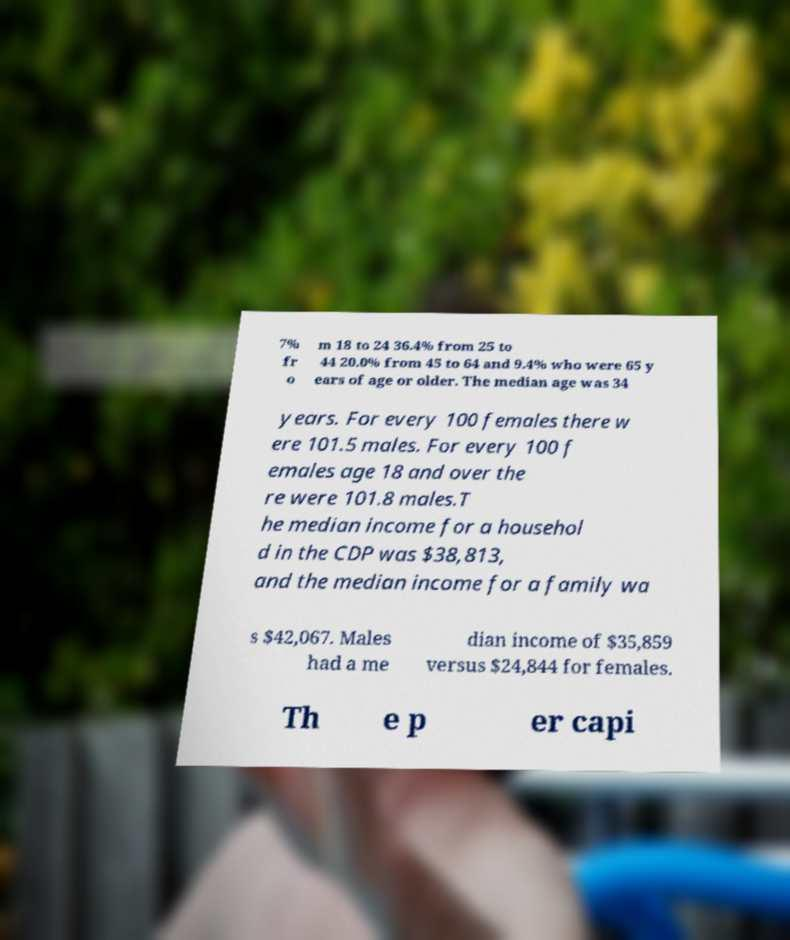What messages or text are displayed in this image? I need them in a readable, typed format. 7% fr o m 18 to 24 36.4% from 25 to 44 20.0% from 45 to 64 and 9.4% who were 65 y ears of age or older. The median age was 34 years. For every 100 females there w ere 101.5 males. For every 100 f emales age 18 and over the re were 101.8 males.T he median income for a househol d in the CDP was $38,813, and the median income for a family wa s $42,067. Males had a me dian income of $35,859 versus $24,844 for females. Th e p er capi 